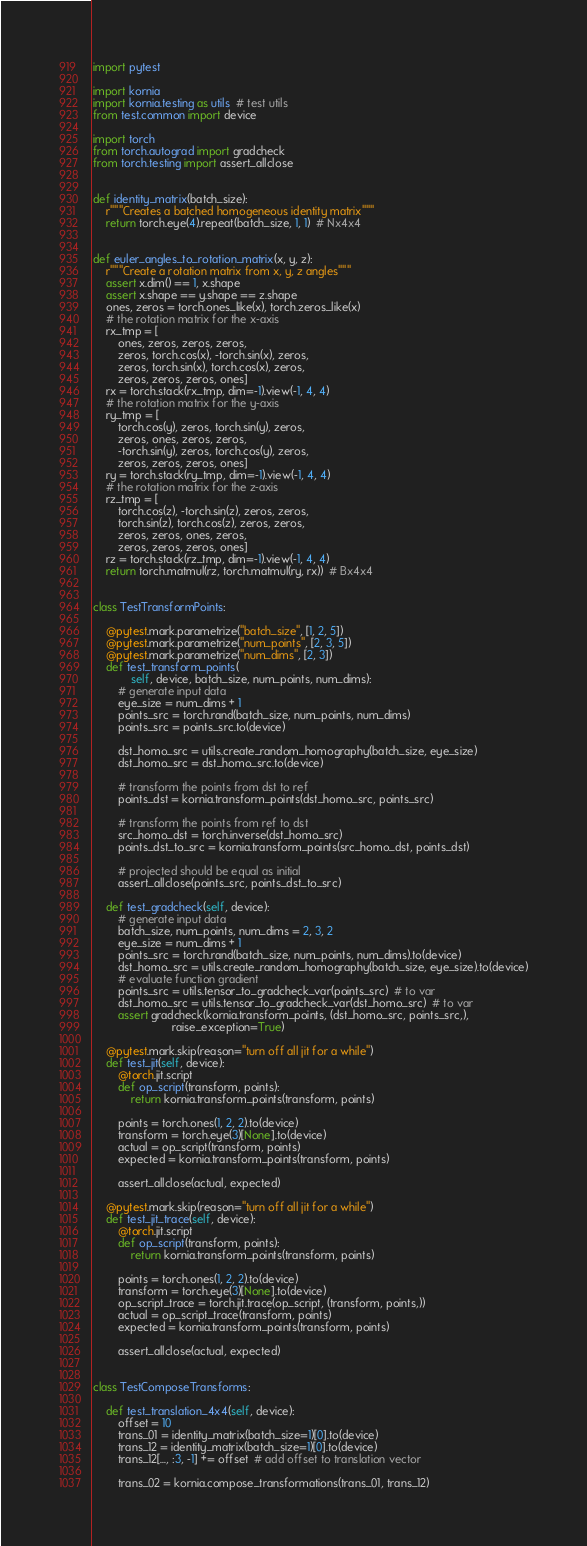Convert code to text. <code><loc_0><loc_0><loc_500><loc_500><_Python_>import pytest

import kornia
import kornia.testing as utils  # test utils
from test.common import device

import torch
from torch.autograd import gradcheck
from torch.testing import assert_allclose


def identity_matrix(batch_size):
    r"""Creates a batched homogeneous identity matrix"""
    return torch.eye(4).repeat(batch_size, 1, 1)  # Nx4x4


def euler_angles_to_rotation_matrix(x, y, z):
    r"""Create a rotation matrix from x, y, z angles"""
    assert x.dim() == 1, x.shape
    assert x.shape == y.shape == z.shape
    ones, zeros = torch.ones_like(x), torch.zeros_like(x)
    # the rotation matrix for the x-axis
    rx_tmp = [
        ones, zeros, zeros, zeros,
        zeros, torch.cos(x), -torch.sin(x), zeros,
        zeros, torch.sin(x), torch.cos(x), zeros,
        zeros, zeros, zeros, ones]
    rx = torch.stack(rx_tmp, dim=-1).view(-1, 4, 4)
    # the rotation matrix for the y-axis
    ry_tmp = [
        torch.cos(y), zeros, torch.sin(y), zeros,
        zeros, ones, zeros, zeros,
        -torch.sin(y), zeros, torch.cos(y), zeros,
        zeros, zeros, zeros, ones]
    ry = torch.stack(ry_tmp, dim=-1).view(-1, 4, 4)
    # the rotation matrix for the z-axis
    rz_tmp = [
        torch.cos(z), -torch.sin(z), zeros, zeros,
        torch.sin(z), torch.cos(z), zeros, zeros,
        zeros, zeros, ones, zeros,
        zeros, zeros, zeros, ones]
    rz = torch.stack(rz_tmp, dim=-1).view(-1, 4, 4)
    return torch.matmul(rz, torch.matmul(ry, rx))  # Bx4x4


class TestTransformPoints:

    @pytest.mark.parametrize("batch_size", [1, 2, 5])
    @pytest.mark.parametrize("num_points", [2, 3, 5])
    @pytest.mark.parametrize("num_dims", [2, 3])
    def test_transform_points(
            self, device, batch_size, num_points, num_dims):
        # generate input data
        eye_size = num_dims + 1
        points_src = torch.rand(batch_size, num_points, num_dims)
        points_src = points_src.to(device)

        dst_homo_src = utils.create_random_homography(batch_size, eye_size)
        dst_homo_src = dst_homo_src.to(device)

        # transform the points from dst to ref
        points_dst = kornia.transform_points(dst_homo_src, points_src)

        # transform the points from ref to dst
        src_homo_dst = torch.inverse(dst_homo_src)
        points_dst_to_src = kornia.transform_points(src_homo_dst, points_dst)

        # projected should be equal as initial
        assert_allclose(points_src, points_dst_to_src)

    def test_gradcheck(self, device):
        # generate input data
        batch_size, num_points, num_dims = 2, 3, 2
        eye_size = num_dims + 1
        points_src = torch.rand(batch_size, num_points, num_dims).to(device)
        dst_homo_src = utils.create_random_homography(batch_size, eye_size).to(device)
        # evaluate function gradient
        points_src = utils.tensor_to_gradcheck_var(points_src)  # to var
        dst_homo_src = utils.tensor_to_gradcheck_var(dst_homo_src)  # to var
        assert gradcheck(kornia.transform_points, (dst_homo_src, points_src,),
                         raise_exception=True)

    @pytest.mark.skip(reason="turn off all jit for a while")
    def test_jit(self, device):
        @torch.jit.script
        def op_script(transform, points):
            return kornia.transform_points(transform, points)

        points = torch.ones(1, 2, 2).to(device)
        transform = torch.eye(3)[None].to(device)
        actual = op_script(transform, points)
        expected = kornia.transform_points(transform, points)

        assert_allclose(actual, expected)

    @pytest.mark.skip(reason="turn off all jit for a while")
    def test_jit_trace(self, device):
        @torch.jit.script
        def op_script(transform, points):
            return kornia.transform_points(transform, points)

        points = torch.ones(1, 2, 2).to(device)
        transform = torch.eye(3)[None].to(device)
        op_script_trace = torch.jit.trace(op_script, (transform, points,))
        actual = op_script_trace(transform, points)
        expected = kornia.transform_points(transform, points)

        assert_allclose(actual, expected)


class TestComposeTransforms:

    def test_translation_4x4(self, device):
        offset = 10
        trans_01 = identity_matrix(batch_size=1)[0].to(device)
        trans_12 = identity_matrix(batch_size=1)[0].to(device)
        trans_12[..., :3, -1] += offset  # add offset to translation vector

        trans_02 = kornia.compose_transformations(trans_01, trans_12)</code> 